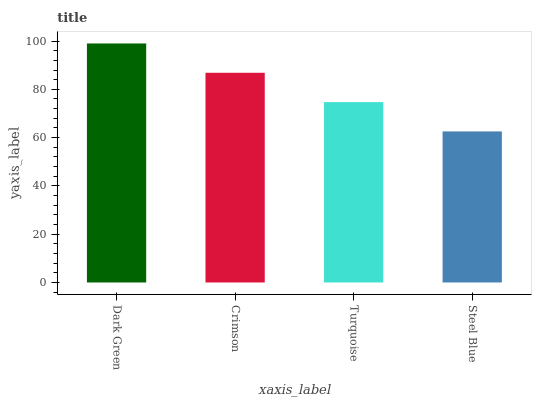Is Steel Blue the minimum?
Answer yes or no. Yes. Is Dark Green the maximum?
Answer yes or no. Yes. Is Crimson the minimum?
Answer yes or no. No. Is Crimson the maximum?
Answer yes or no. No. Is Dark Green greater than Crimson?
Answer yes or no. Yes. Is Crimson less than Dark Green?
Answer yes or no. Yes. Is Crimson greater than Dark Green?
Answer yes or no. No. Is Dark Green less than Crimson?
Answer yes or no. No. Is Crimson the high median?
Answer yes or no. Yes. Is Turquoise the low median?
Answer yes or no. Yes. Is Turquoise the high median?
Answer yes or no. No. Is Crimson the low median?
Answer yes or no. No. 